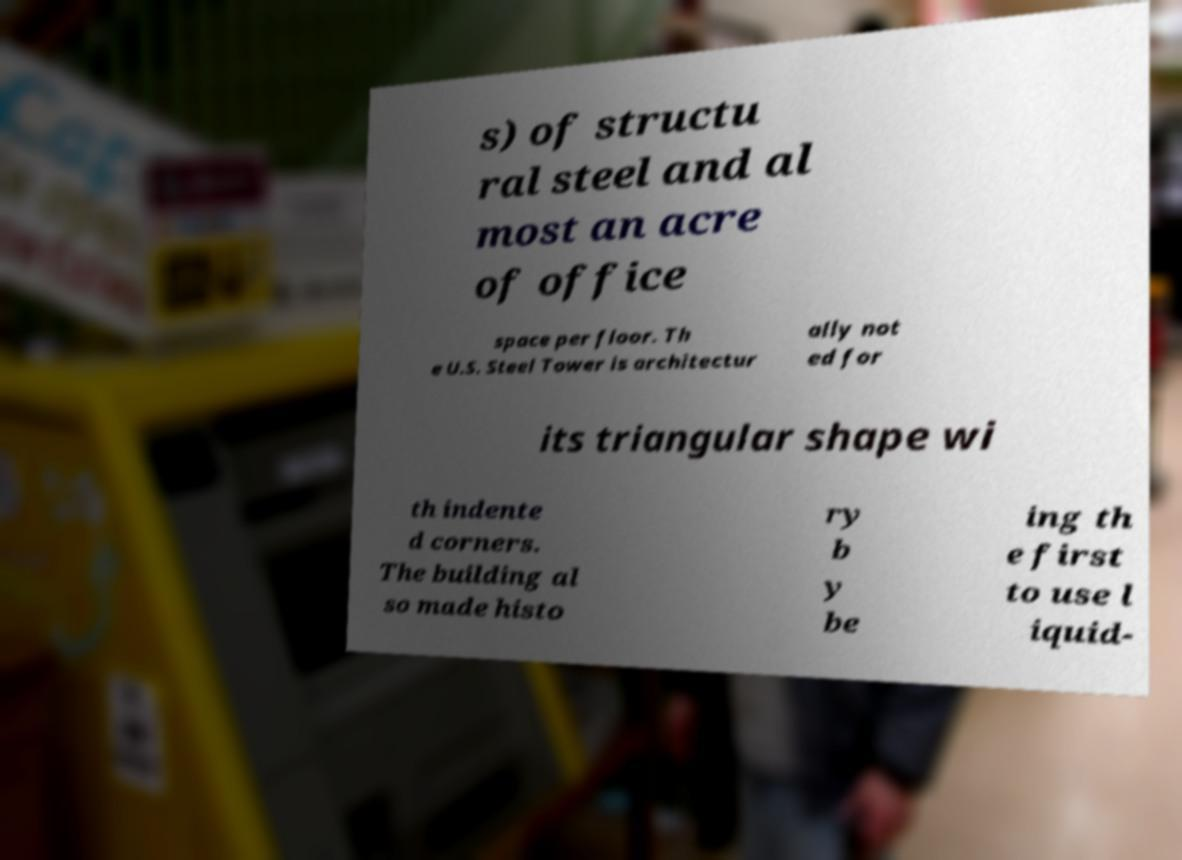What messages or text are displayed in this image? I need them in a readable, typed format. s) of structu ral steel and al most an acre of office space per floor. Th e U.S. Steel Tower is architectur ally not ed for its triangular shape wi th indente d corners. The building al so made histo ry b y be ing th e first to use l iquid- 